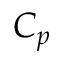<formula> <loc_0><loc_0><loc_500><loc_500>C _ { p }</formula> 